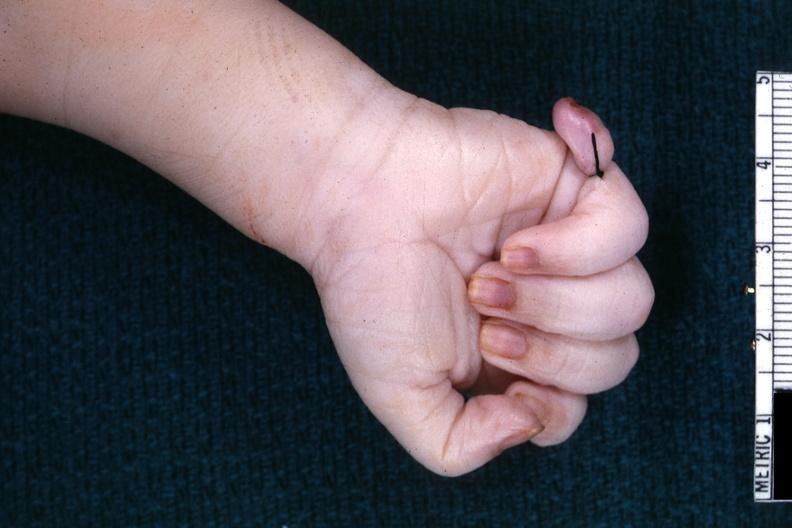does this image show good shot of sixth finger with ligature on it?
Answer the question using a single word or phrase. Yes 